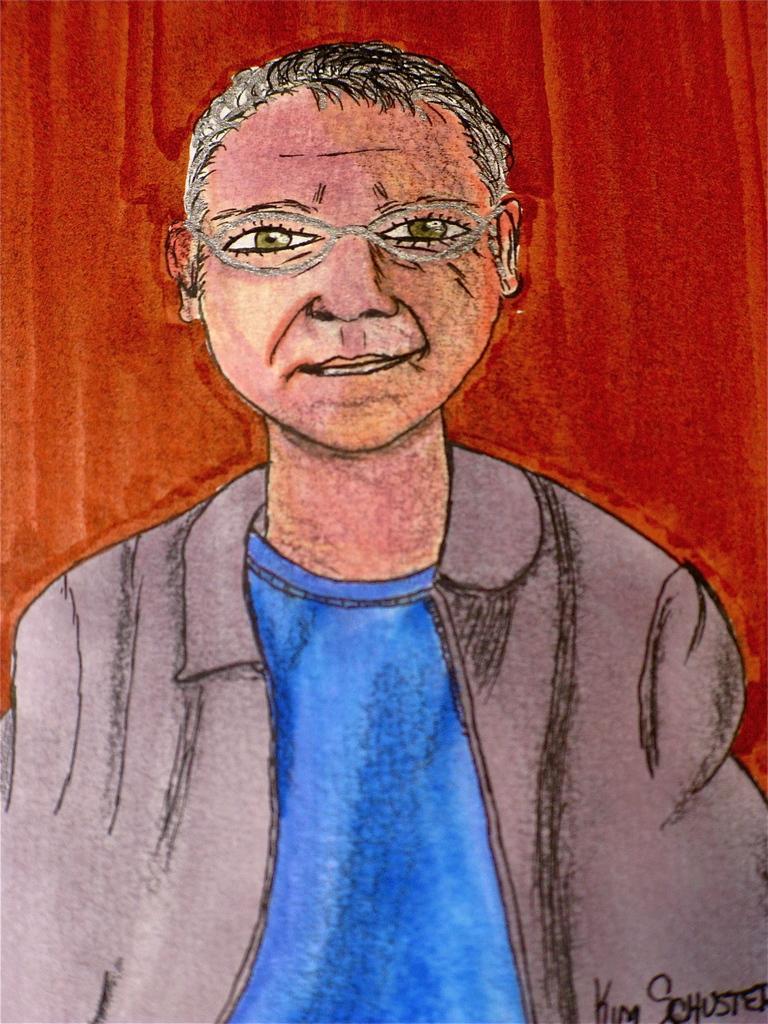Can you describe this image briefly? In this image I can see the sketch of a person. This person is wearing a jacket and smiling. The background is in red color. 